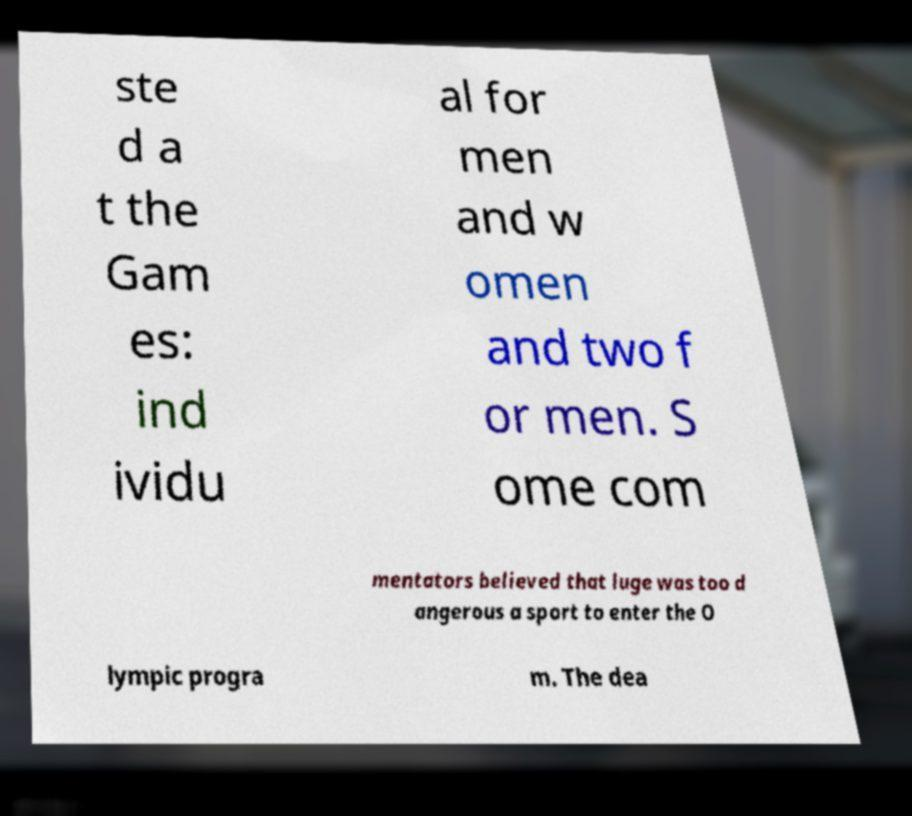Could you extract and type out the text from this image? ste d a t the Gam es: ind ividu al for men and w omen and two f or men. S ome com mentators believed that luge was too d angerous a sport to enter the O lympic progra m. The dea 